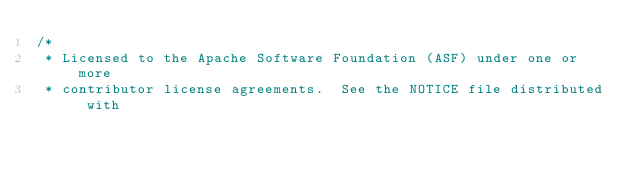Convert code to text. <code><loc_0><loc_0><loc_500><loc_500><_Java_>/*
 * Licensed to the Apache Software Foundation (ASF) under one or more
 * contributor license agreements.  See the NOTICE file distributed with</code> 